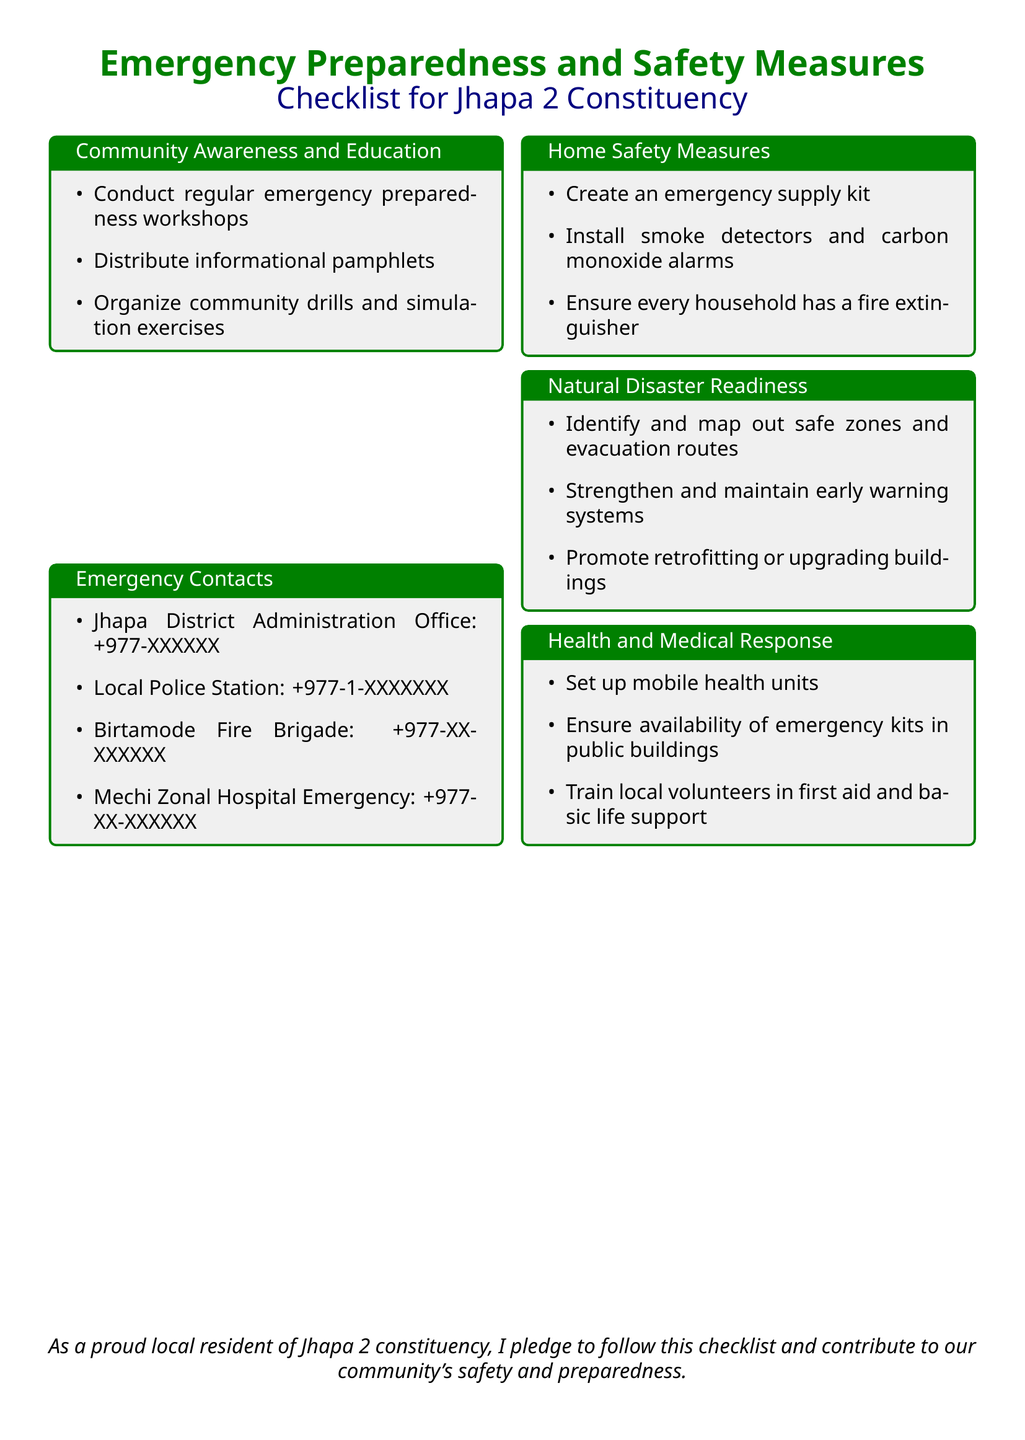What are the emergency contacts provided? The document lists various emergency contacts including local police and fire brigade numbers.
Answer: Local Police Station: +977-1-XXXXXXX, Birtamode Fire Brigade: +977-XX-XXXXXX How many categories are there in the checklist? There are five distinct categories or sections in the checklist highlighting different aspects of emergency preparedness.
Answer: Five What is one measure suggested for home safety? The document lists several measures for home safety, including creating an emergency supply kit.
Answer: Create an emergency supply kit What should be done to enhance community awareness? The checklist suggests organizing community drills as a way to improve emergency preparedness and awareness.
Answer: Organize community drills What is the purpose of emergency kits in public buildings? The document specifies that emergency kits are vital for health and medical response in case of emergencies.
Answer: Health and medical response Which organization is responsible for maintaining early warning systems? The document emphasizes that strengthening early warning systems is part of natural disaster readiness, implying it involves local governance or relevant agencies.
Answer: Local governance or relevant agencies How are local volunteers prepared for emergencies? The checklist emphasizes training local volunteers in first aid and basic life support as a measure for health and medical response.
Answer: Train local volunteers in first aid and basic life support What is an aspect of natural disaster readiness mentioned? The document mentions identifying and mapping out safe zones and evacuation routes as part of natural disaster readiness measures.
Answer: Identify and map out safe zones and evacuation routes What action is recommended for building safety? The checklist suggests promoting retrofitting or upgrading buildings to enhance safety against disasters.
Answer: Promote retrofitting or upgrading buildings 